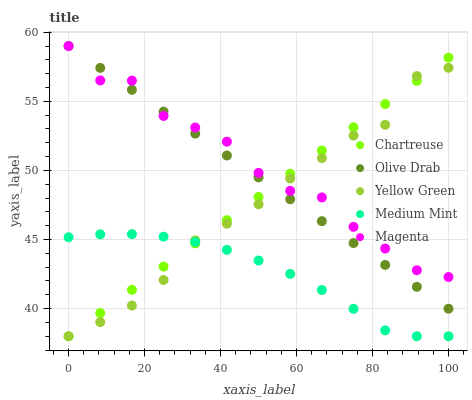Does Medium Mint have the minimum area under the curve?
Answer yes or no. Yes. Does Magenta have the maximum area under the curve?
Answer yes or no. Yes. Does Chartreuse have the minimum area under the curve?
Answer yes or no. No. Does Chartreuse have the maximum area under the curve?
Answer yes or no. No. Is Chartreuse the smoothest?
Answer yes or no. Yes. Is Magenta the roughest?
Answer yes or no. Yes. Is Magenta the smoothest?
Answer yes or no. No. Is Chartreuse the roughest?
Answer yes or no. No. Does Medium Mint have the lowest value?
Answer yes or no. Yes. Does Magenta have the lowest value?
Answer yes or no. No. Does Olive Drab have the highest value?
Answer yes or no. Yes. Does Chartreuse have the highest value?
Answer yes or no. No. Is Medium Mint less than Olive Drab?
Answer yes or no. Yes. Is Magenta greater than Medium Mint?
Answer yes or no. Yes. Does Medium Mint intersect Chartreuse?
Answer yes or no. Yes. Is Medium Mint less than Chartreuse?
Answer yes or no. No. Is Medium Mint greater than Chartreuse?
Answer yes or no. No. Does Medium Mint intersect Olive Drab?
Answer yes or no. No. 